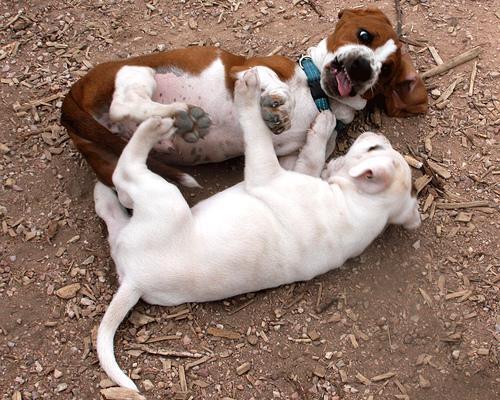How many dogs can be seen?
Give a very brief answer. 2. 